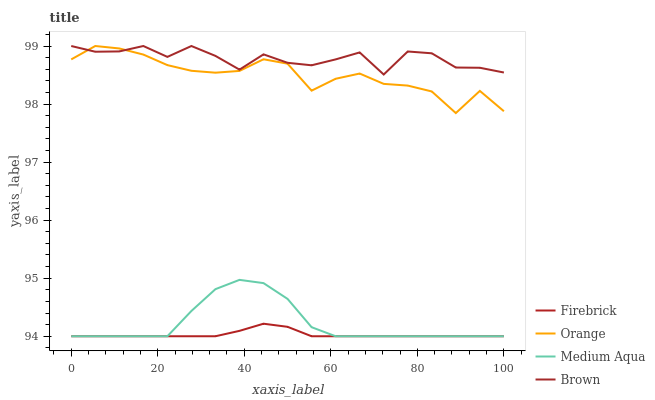Does Firebrick have the minimum area under the curve?
Answer yes or no. Yes. Does Brown have the maximum area under the curve?
Answer yes or no. Yes. Does Brown have the minimum area under the curve?
Answer yes or no. No. Does Firebrick have the maximum area under the curve?
Answer yes or no. No. Is Firebrick the smoothest?
Answer yes or no. Yes. Is Brown the roughest?
Answer yes or no. Yes. Is Brown the smoothest?
Answer yes or no. No. Is Firebrick the roughest?
Answer yes or no. No. Does Firebrick have the lowest value?
Answer yes or no. Yes. Does Brown have the lowest value?
Answer yes or no. No. Does Brown have the highest value?
Answer yes or no. Yes. Does Firebrick have the highest value?
Answer yes or no. No. Is Medium Aqua less than Orange?
Answer yes or no. Yes. Is Brown greater than Medium Aqua?
Answer yes or no. Yes. Does Firebrick intersect Medium Aqua?
Answer yes or no. Yes. Is Firebrick less than Medium Aqua?
Answer yes or no. No. Is Firebrick greater than Medium Aqua?
Answer yes or no. No. Does Medium Aqua intersect Orange?
Answer yes or no. No. 